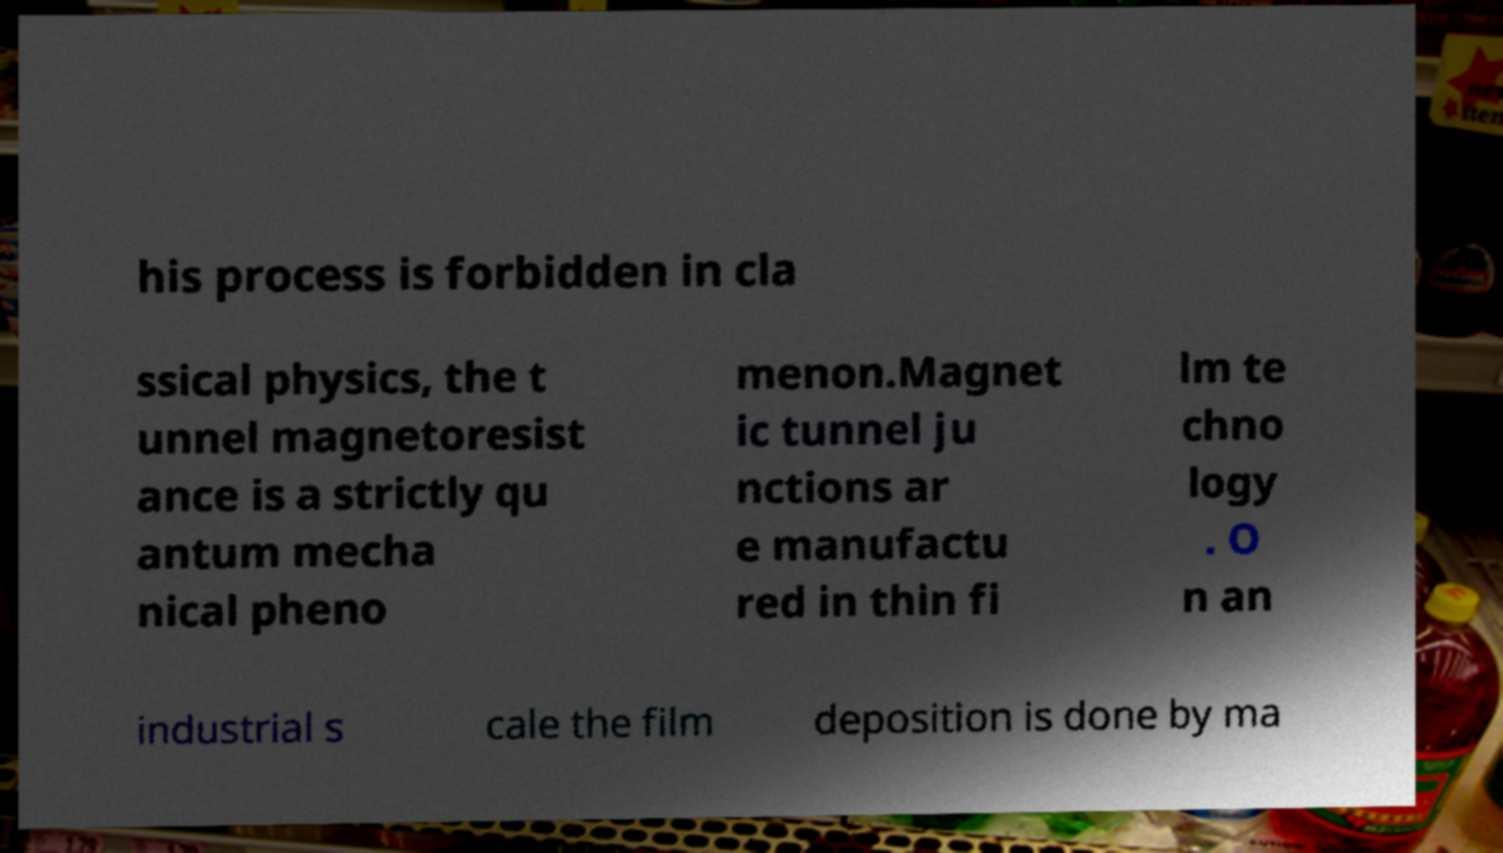For documentation purposes, I need the text within this image transcribed. Could you provide that? his process is forbidden in cla ssical physics, the t unnel magnetoresist ance is a strictly qu antum mecha nical pheno menon.Magnet ic tunnel ju nctions ar e manufactu red in thin fi lm te chno logy . O n an industrial s cale the film deposition is done by ma 